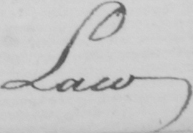What does this handwritten line say? Law , 